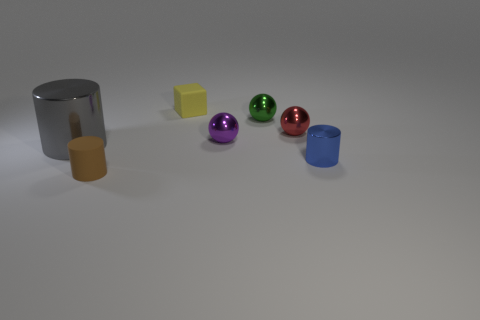Are there any other things that are the same size as the gray thing?
Keep it short and to the point. No. The brown thing that is to the left of the tiny shiny object in front of the big gray thing is what shape?
Offer a very short reply. Cylinder. There is another tiny object that is the same material as the small brown object; what is its shape?
Provide a short and direct response. Cube. How many other objects are the same shape as the purple shiny object?
Ensure brevity in your answer.  2. Does the rubber object that is behind the purple sphere have the same size as the red metallic thing?
Your answer should be very brief. Yes. Is the number of tiny red shiny things that are in front of the matte block greater than the number of purple cylinders?
Offer a terse response. Yes. How many tiny green metallic objects are in front of the small rubber object that is behind the small green object?
Provide a short and direct response. 1. Is the number of tiny metal spheres behind the tiny yellow rubber object less than the number of tiny red matte blocks?
Keep it short and to the point. No. There is a shiny cylinder behind the cylinder that is on the right side of the tiny green object; is there a tiny block to the left of it?
Offer a terse response. No. Are the blue thing and the cylinder on the left side of the small rubber cylinder made of the same material?
Provide a short and direct response. Yes. 